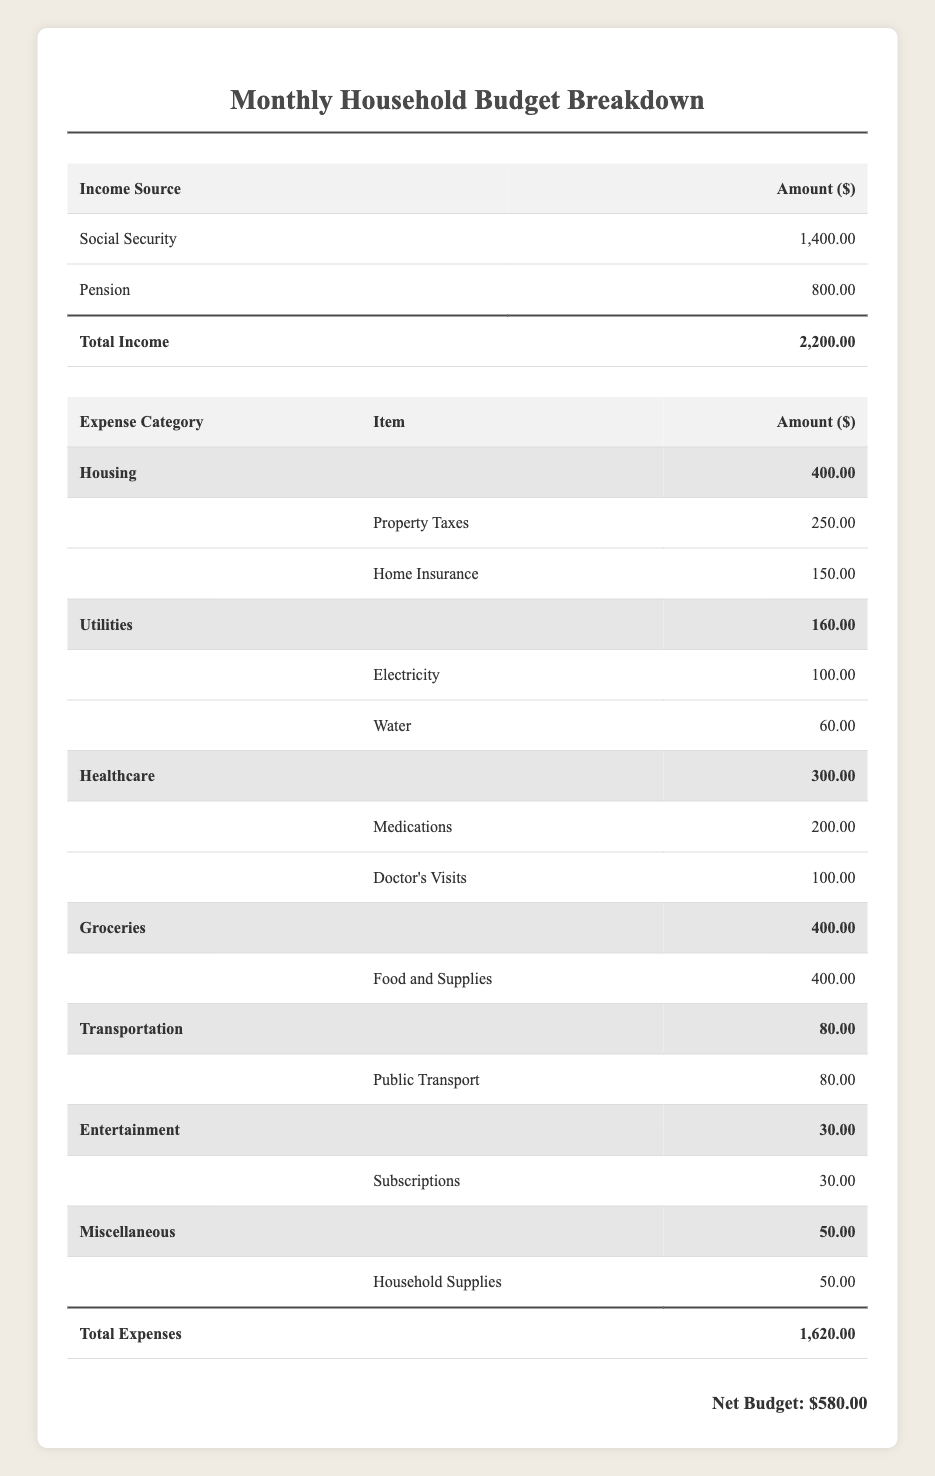What is the total income for the month? The total income is given in the income section of the table under "Total Income," which states it is $2,200.
Answer: $2,200 How much is spent on healthcare? The expenses listed under the "Healthcare" category total $300 (Medications $200 + Doctor's Visits $100).
Answer: $300 What is the net budget after expenses? The net budget is provided at the bottom of the table, which states it is $580 after subtracting total expenses from total income.
Answer: $580 Are the monthly groceries expenses greater than transportation costs? The groceries total $400, while transportation expenses are $80, indicating that groceries are indeed greater.
Answer: Yes What are the total housing expenses? The housing expenses include Property Taxes ($250) and Home Insurance ($150), which sum to $400.
Answer: $400 How much is spent on utilities compared to entertainment? Total utilities expenses are $160 (Electricity $100 + Water $60) and entertainment expenses are $30; thus, utilities expenses are significantly higher than entertainment.
Answer: Utilities are higher What percentage of income is allocated to housing expenses? The housing expenses ($400) are divided by the total income ($2,200) which gives (400/2200)*100 = 18.18%, meaning 18.18% of income goes to housing.
Answer: 18.18% If I wanted to save half of the net budget, how much would I have left? Saving half of the net budget ($580), which is $290, means I would have $290 remaining in the net budget if I saved that amount.
Answer: $290 How much more is spent on groceries compared to public transport? Groceries are $400, and public transport is $80, so the difference is $400 - $80 = $320 indicating significantly more is spent on groceries.
Answer: $320 What is the total amount spent on miscellaneous items? The miscellaneous category shows one item, Household Supplies, which costs $50, therefore the total amount spent on miscellaneous items is $50.
Answer: $50 